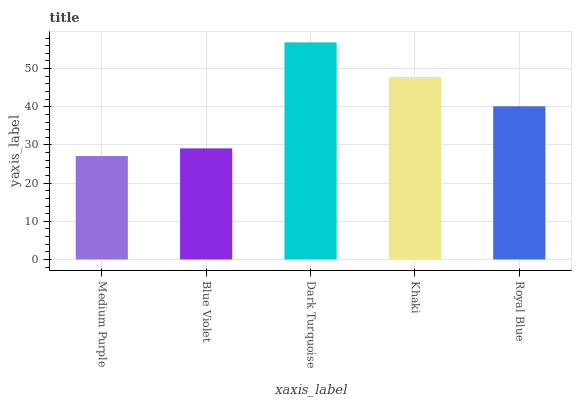Is Medium Purple the minimum?
Answer yes or no. Yes. Is Dark Turquoise the maximum?
Answer yes or no. Yes. Is Blue Violet the minimum?
Answer yes or no. No. Is Blue Violet the maximum?
Answer yes or no. No. Is Blue Violet greater than Medium Purple?
Answer yes or no. Yes. Is Medium Purple less than Blue Violet?
Answer yes or no. Yes. Is Medium Purple greater than Blue Violet?
Answer yes or no. No. Is Blue Violet less than Medium Purple?
Answer yes or no. No. Is Royal Blue the high median?
Answer yes or no. Yes. Is Royal Blue the low median?
Answer yes or no. Yes. Is Dark Turquoise the high median?
Answer yes or no. No. Is Khaki the low median?
Answer yes or no. No. 